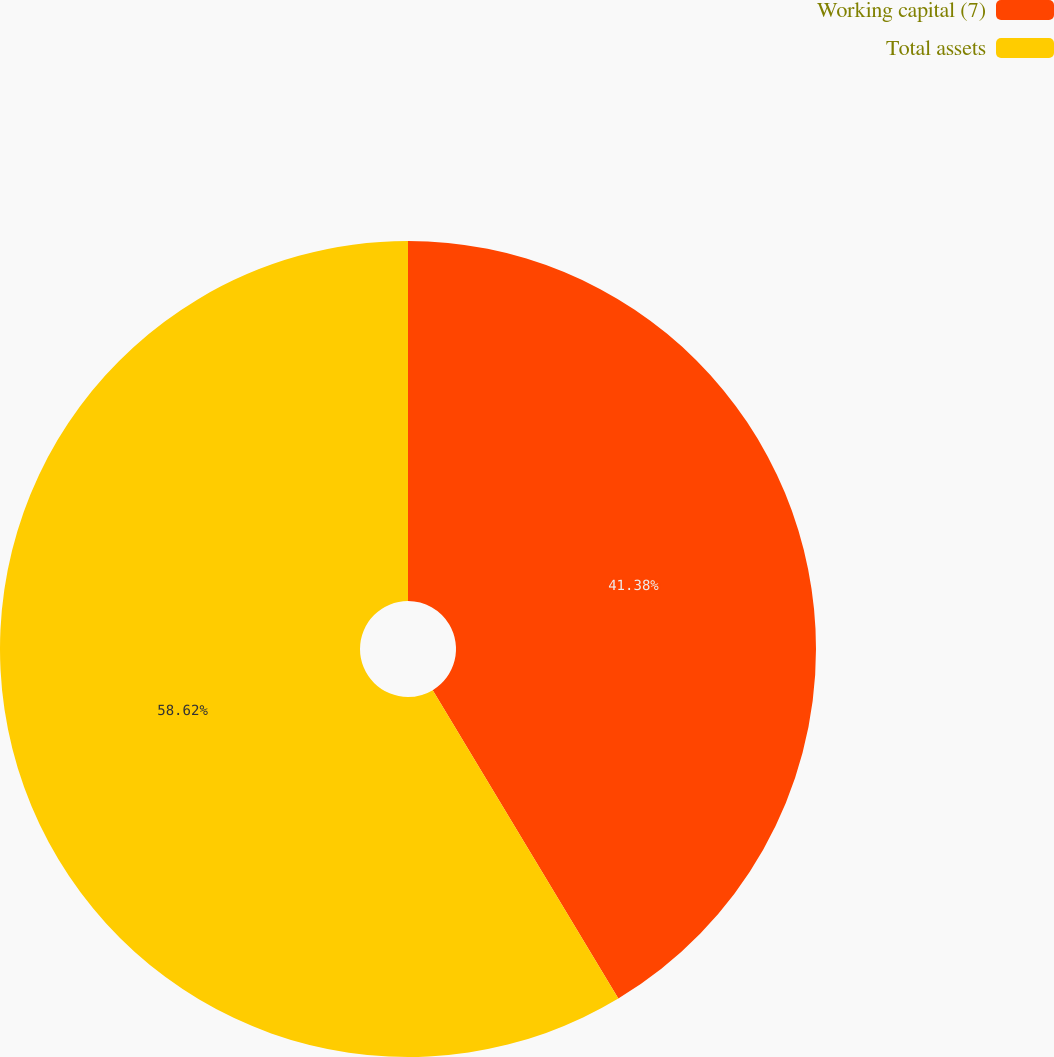<chart> <loc_0><loc_0><loc_500><loc_500><pie_chart><fcel>Working capital (7)<fcel>Total assets<nl><fcel>41.38%<fcel>58.62%<nl></chart> 